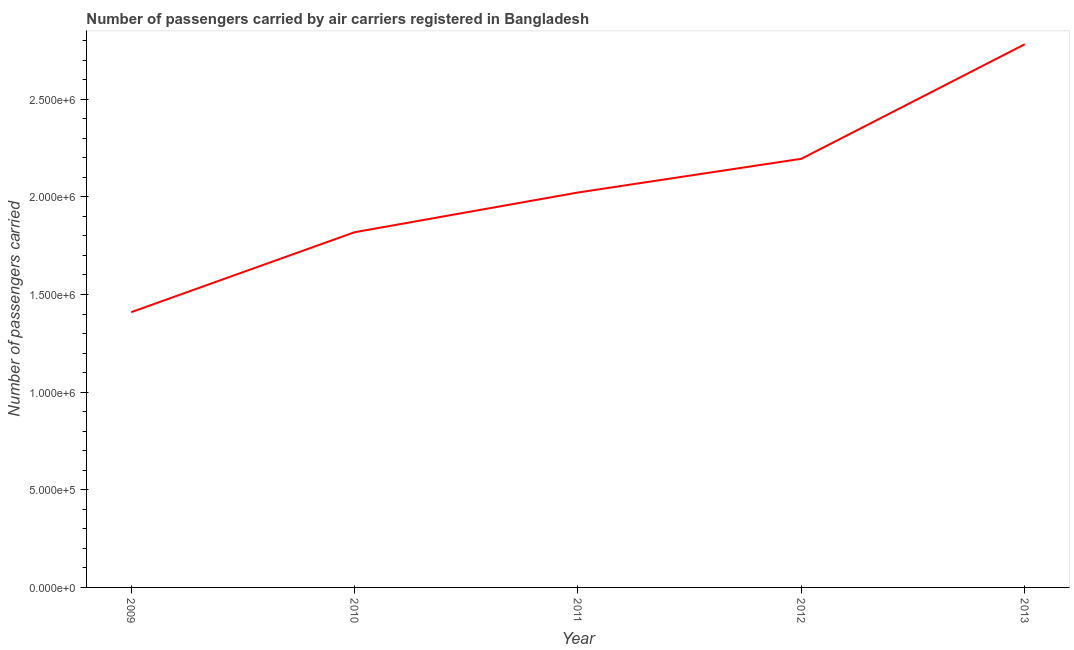What is the number of passengers carried in 2011?
Provide a short and direct response. 2.02e+06. Across all years, what is the maximum number of passengers carried?
Make the answer very short. 2.78e+06. Across all years, what is the minimum number of passengers carried?
Your response must be concise. 1.41e+06. What is the sum of the number of passengers carried?
Your answer should be very brief. 1.02e+07. What is the difference between the number of passengers carried in 2011 and 2012?
Offer a very short reply. -1.73e+05. What is the average number of passengers carried per year?
Keep it short and to the point. 2.05e+06. What is the median number of passengers carried?
Your answer should be compact. 2.02e+06. In how many years, is the number of passengers carried greater than 1500000 ?
Your answer should be compact. 4. What is the ratio of the number of passengers carried in 2010 to that in 2011?
Ensure brevity in your answer.  0.9. Is the difference between the number of passengers carried in 2009 and 2011 greater than the difference between any two years?
Offer a terse response. No. What is the difference between the highest and the second highest number of passengers carried?
Your response must be concise. 5.87e+05. What is the difference between the highest and the lowest number of passengers carried?
Provide a short and direct response. 1.37e+06. In how many years, is the number of passengers carried greater than the average number of passengers carried taken over all years?
Offer a very short reply. 2. Does the number of passengers carried monotonically increase over the years?
Give a very brief answer. Yes. How many years are there in the graph?
Give a very brief answer. 5. Does the graph contain any zero values?
Make the answer very short. No. Does the graph contain grids?
Your answer should be very brief. No. What is the title of the graph?
Offer a very short reply. Number of passengers carried by air carriers registered in Bangladesh. What is the label or title of the Y-axis?
Offer a terse response. Number of passengers carried. What is the Number of passengers carried of 2009?
Give a very brief answer. 1.41e+06. What is the Number of passengers carried of 2010?
Keep it short and to the point. 1.82e+06. What is the Number of passengers carried in 2011?
Keep it short and to the point. 2.02e+06. What is the Number of passengers carried of 2012?
Your answer should be very brief. 2.20e+06. What is the Number of passengers carried in 2013?
Your answer should be compact. 2.78e+06. What is the difference between the Number of passengers carried in 2009 and 2010?
Keep it short and to the point. -4.09e+05. What is the difference between the Number of passengers carried in 2009 and 2011?
Your answer should be very brief. -6.13e+05. What is the difference between the Number of passengers carried in 2009 and 2012?
Give a very brief answer. -7.86e+05. What is the difference between the Number of passengers carried in 2009 and 2013?
Offer a very short reply. -1.37e+06. What is the difference between the Number of passengers carried in 2010 and 2011?
Offer a very short reply. -2.03e+05. What is the difference between the Number of passengers carried in 2010 and 2012?
Make the answer very short. -3.76e+05. What is the difference between the Number of passengers carried in 2010 and 2013?
Make the answer very short. -9.63e+05. What is the difference between the Number of passengers carried in 2011 and 2012?
Provide a short and direct response. -1.73e+05. What is the difference between the Number of passengers carried in 2011 and 2013?
Provide a succinct answer. -7.59e+05. What is the difference between the Number of passengers carried in 2012 and 2013?
Offer a very short reply. -5.87e+05. What is the ratio of the Number of passengers carried in 2009 to that in 2010?
Ensure brevity in your answer.  0.78. What is the ratio of the Number of passengers carried in 2009 to that in 2011?
Keep it short and to the point. 0.7. What is the ratio of the Number of passengers carried in 2009 to that in 2012?
Ensure brevity in your answer.  0.64. What is the ratio of the Number of passengers carried in 2009 to that in 2013?
Your answer should be compact. 0.51. What is the ratio of the Number of passengers carried in 2010 to that in 2011?
Your answer should be compact. 0.9. What is the ratio of the Number of passengers carried in 2010 to that in 2012?
Offer a very short reply. 0.83. What is the ratio of the Number of passengers carried in 2010 to that in 2013?
Your answer should be compact. 0.65. What is the ratio of the Number of passengers carried in 2011 to that in 2012?
Offer a terse response. 0.92. What is the ratio of the Number of passengers carried in 2011 to that in 2013?
Your response must be concise. 0.73. What is the ratio of the Number of passengers carried in 2012 to that in 2013?
Keep it short and to the point. 0.79. 